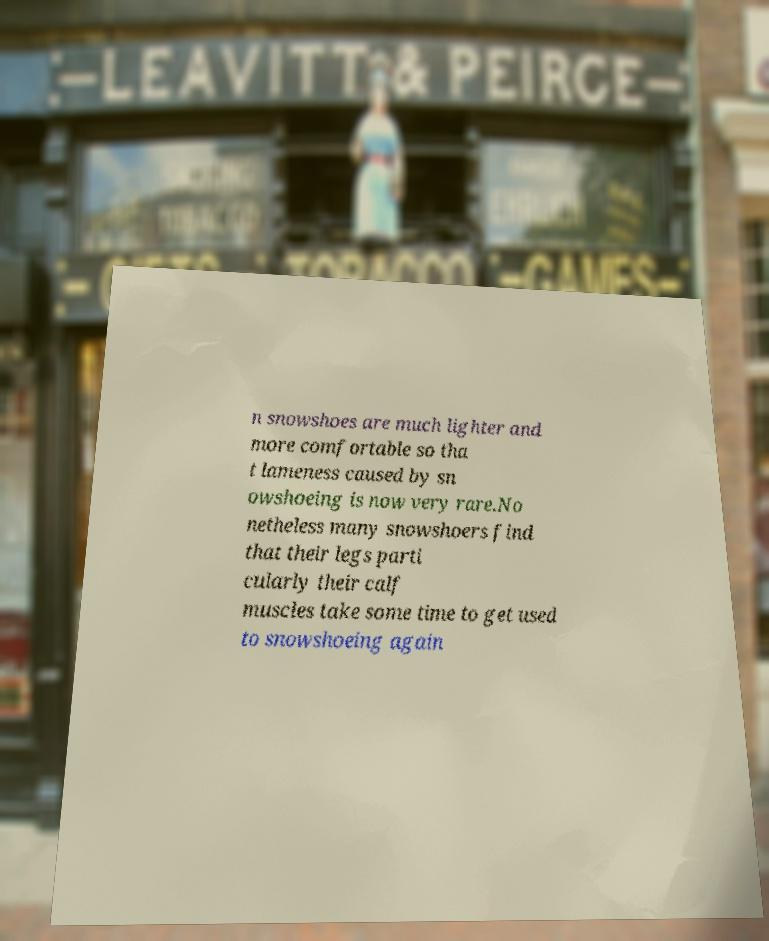Can you read and provide the text displayed in the image?This photo seems to have some interesting text. Can you extract and type it out for me? n snowshoes are much lighter and more comfortable so tha t lameness caused by sn owshoeing is now very rare.No netheless many snowshoers find that their legs parti cularly their calf muscles take some time to get used to snowshoeing again 